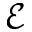<formula> <loc_0><loc_0><loc_500><loc_500>\mathcal { E }</formula> 